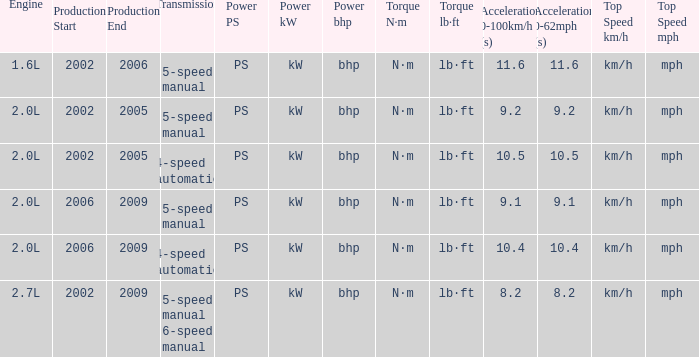What is the top speed of a 5-speed manual transmission produced in 2006-2009? Km/h (mph). 